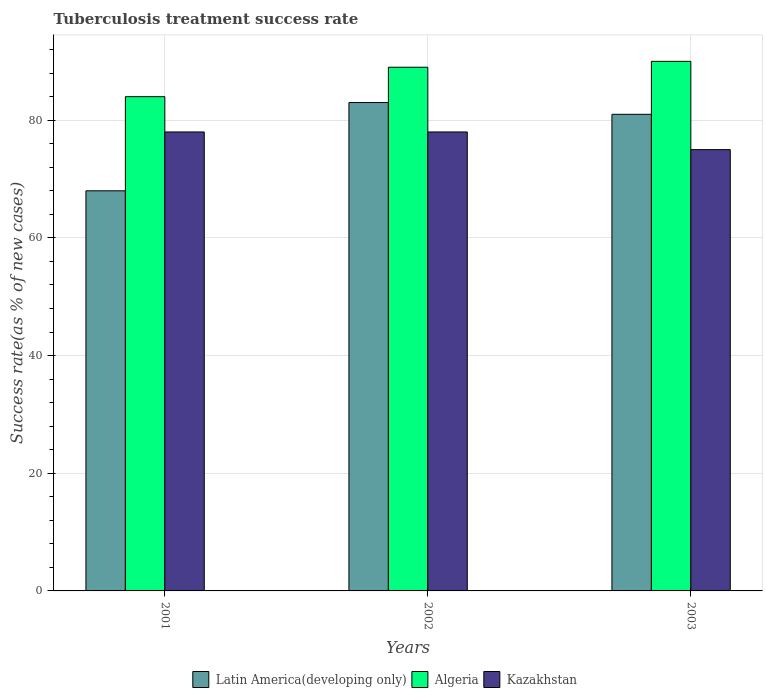How many different coloured bars are there?
Make the answer very short. 3. Are the number of bars per tick equal to the number of legend labels?
Offer a terse response. Yes. How many bars are there on the 3rd tick from the right?
Ensure brevity in your answer.  3. In how many cases, is the number of bars for a given year not equal to the number of legend labels?
Your answer should be very brief. 0. What is the tuberculosis treatment success rate in Latin America(developing only) in 2003?
Your answer should be very brief. 81. Across all years, what is the minimum tuberculosis treatment success rate in Algeria?
Offer a very short reply. 84. What is the total tuberculosis treatment success rate in Algeria in the graph?
Ensure brevity in your answer.  263. What is the difference between the tuberculosis treatment success rate in Kazakhstan in 2003 and the tuberculosis treatment success rate in Algeria in 2002?
Your answer should be very brief. -14. What is the average tuberculosis treatment success rate in Latin America(developing only) per year?
Make the answer very short. 77.33. In the year 2002, what is the difference between the tuberculosis treatment success rate in Kazakhstan and tuberculosis treatment success rate in Algeria?
Your answer should be very brief. -11. In how many years, is the tuberculosis treatment success rate in Latin America(developing only) greater than 76 %?
Your answer should be very brief. 2. What is the ratio of the tuberculosis treatment success rate in Latin America(developing only) in 2001 to that in 2002?
Keep it short and to the point. 0.82. Is the tuberculosis treatment success rate in Kazakhstan in 2001 less than that in 2002?
Make the answer very short. No. Is the difference between the tuberculosis treatment success rate in Kazakhstan in 2001 and 2003 greater than the difference between the tuberculosis treatment success rate in Algeria in 2001 and 2003?
Your answer should be very brief. Yes. What is the difference between the highest and the second highest tuberculosis treatment success rate in Latin America(developing only)?
Provide a succinct answer. 2. What is the difference between the highest and the lowest tuberculosis treatment success rate in Latin America(developing only)?
Offer a very short reply. 15. In how many years, is the tuberculosis treatment success rate in Algeria greater than the average tuberculosis treatment success rate in Algeria taken over all years?
Make the answer very short. 2. What does the 1st bar from the left in 2002 represents?
Ensure brevity in your answer.  Latin America(developing only). What does the 3rd bar from the right in 2002 represents?
Give a very brief answer. Latin America(developing only). What is the difference between two consecutive major ticks on the Y-axis?
Provide a succinct answer. 20. Are the values on the major ticks of Y-axis written in scientific E-notation?
Ensure brevity in your answer.  No. Does the graph contain any zero values?
Offer a terse response. No. Where does the legend appear in the graph?
Offer a terse response. Bottom center. How are the legend labels stacked?
Your response must be concise. Horizontal. What is the title of the graph?
Provide a short and direct response. Tuberculosis treatment success rate. Does "Bhutan" appear as one of the legend labels in the graph?
Your answer should be compact. No. What is the label or title of the Y-axis?
Provide a succinct answer. Success rate(as % of new cases). What is the Success rate(as % of new cases) in Kazakhstan in 2001?
Your answer should be very brief. 78. What is the Success rate(as % of new cases) in Latin America(developing only) in 2002?
Your response must be concise. 83. What is the Success rate(as % of new cases) of Algeria in 2002?
Your response must be concise. 89. What is the Success rate(as % of new cases) of Algeria in 2003?
Make the answer very short. 90. Across all years, what is the maximum Success rate(as % of new cases) in Latin America(developing only)?
Make the answer very short. 83. Across all years, what is the maximum Success rate(as % of new cases) in Kazakhstan?
Ensure brevity in your answer.  78. Across all years, what is the minimum Success rate(as % of new cases) in Algeria?
Provide a short and direct response. 84. Across all years, what is the minimum Success rate(as % of new cases) of Kazakhstan?
Keep it short and to the point. 75. What is the total Success rate(as % of new cases) in Latin America(developing only) in the graph?
Your response must be concise. 232. What is the total Success rate(as % of new cases) in Algeria in the graph?
Your answer should be very brief. 263. What is the total Success rate(as % of new cases) of Kazakhstan in the graph?
Keep it short and to the point. 231. What is the difference between the Success rate(as % of new cases) of Latin America(developing only) in 2001 and that in 2002?
Provide a short and direct response. -15. What is the difference between the Success rate(as % of new cases) of Latin America(developing only) in 2001 and that in 2003?
Give a very brief answer. -13. What is the difference between the Success rate(as % of new cases) in Kazakhstan in 2001 and that in 2003?
Your response must be concise. 3. What is the difference between the Success rate(as % of new cases) in Algeria in 2002 and that in 2003?
Offer a terse response. -1. What is the difference between the Success rate(as % of new cases) in Kazakhstan in 2002 and that in 2003?
Your response must be concise. 3. What is the difference between the Success rate(as % of new cases) in Algeria in 2001 and the Success rate(as % of new cases) in Kazakhstan in 2002?
Your answer should be compact. 6. What is the difference between the Success rate(as % of new cases) of Latin America(developing only) in 2001 and the Success rate(as % of new cases) of Kazakhstan in 2003?
Your answer should be very brief. -7. What is the difference between the Success rate(as % of new cases) in Algeria in 2001 and the Success rate(as % of new cases) in Kazakhstan in 2003?
Provide a short and direct response. 9. What is the difference between the Success rate(as % of new cases) of Latin America(developing only) in 2002 and the Success rate(as % of new cases) of Kazakhstan in 2003?
Provide a short and direct response. 8. What is the difference between the Success rate(as % of new cases) in Algeria in 2002 and the Success rate(as % of new cases) in Kazakhstan in 2003?
Make the answer very short. 14. What is the average Success rate(as % of new cases) in Latin America(developing only) per year?
Your answer should be compact. 77.33. What is the average Success rate(as % of new cases) in Algeria per year?
Your response must be concise. 87.67. In the year 2001, what is the difference between the Success rate(as % of new cases) of Latin America(developing only) and Success rate(as % of new cases) of Algeria?
Offer a very short reply. -16. In the year 2002, what is the difference between the Success rate(as % of new cases) of Latin America(developing only) and Success rate(as % of new cases) of Kazakhstan?
Keep it short and to the point. 5. In the year 2003, what is the difference between the Success rate(as % of new cases) in Latin America(developing only) and Success rate(as % of new cases) in Algeria?
Provide a succinct answer. -9. In the year 2003, what is the difference between the Success rate(as % of new cases) in Latin America(developing only) and Success rate(as % of new cases) in Kazakhstan?
Offer a terse response. 6. In the year 2003, what is the difference between the Success rate(as % of new cases) of Algeria and Success rate(as % of new cases) of Kazakhstan?
Your answer should be compact. 15. What is the ratio of the Success rate(as % of new cases) of Latin America(developing only) in 2001 to that in 2002?
Your answer should be very brief. 0.82. What is the ratio of the Success rate(as % of new cases) in Algeria in 2001 to that in 2002?
Offer a very short reply. 0.94. What is the ratio of the Success rate(as % of new cases) of Kazakhstan in 2001 to that in 2002?
Your answer should be compact. 1. What is the ratio of the Success rate(as % of new cases) in Latin America(developing only) in 2001 to that in 2003?
Give a very brief answer. 0.84. What is the ratio of the Success rate(as % of new cases) in Latin America(developing only) in 2002 to that in 2003?
Provide a succinct answer. 1.02. What is the ratio of the Success rate(as % of new cases) in Algeria in 2002 to that in 2003?
Keep it short and to the point. 0.99. What is the ratio of the Success rate(as % of new cases) of Kazakhstan in 2002 to that in 2003?
Offer a very short reply. 1.04. What is the difference between the highest and the second highest Success rate(as % of new cases) of Kazakhstan?
Keep it short and to the point. 0. What is the difference between the highest and the lowest Success rate(as % of new cases) of Latin America(developing only)?
Give a very brief answer. 15. What is the difference between the highest and the lowest Success rate(as % of new cases) in Algeria?
Keep it short and to the point. 6. What is the difference between the highest and the lowest Success rate(as % of new cases) of Kazakhstan?
Your answer should be very brief. 3. 